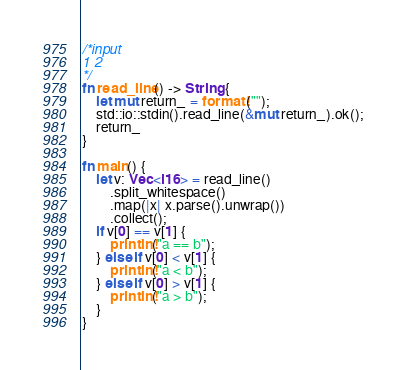<code> <loc_0><loc_0><loc_500><loc_500><_Rust_>/*input
1 2
*/
fn read_line() -> String {
    let mut return_ = format!("");
    std::io::stdin().read_line(&mut return_).ok();
    return_
}

fn main() {
    let v: Vec<i16> = read_line()
        .split_whitespace()
        .map(|x| x.parse().unwrap())
        .collect();
    if v[0] == v[1] {
        println!("a == b");
    } else if v[0] < v[1] {
        println!("a < b");
    } else if v[0] > v[1] {
        println!("a > b");
    }
}

</code> 